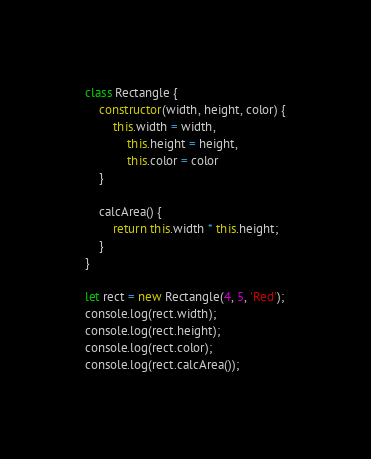Convert code to text. <code><loc_0><loc_0><loc_500><loc_500><_JavaScript_>class Rectangle {
    constructor(width, height, color) {
        this.width = width,
            this.height = height,
            this.color = color
    }

    calcArea() {
        return this.width * this.height;
    }
}

let rect = new Rectangle(4, 5, 'Red');
console.log(rect.width);
console.log(rect.height);
console.log(rect.color);
console.log(rect.calcArea());


</code> 